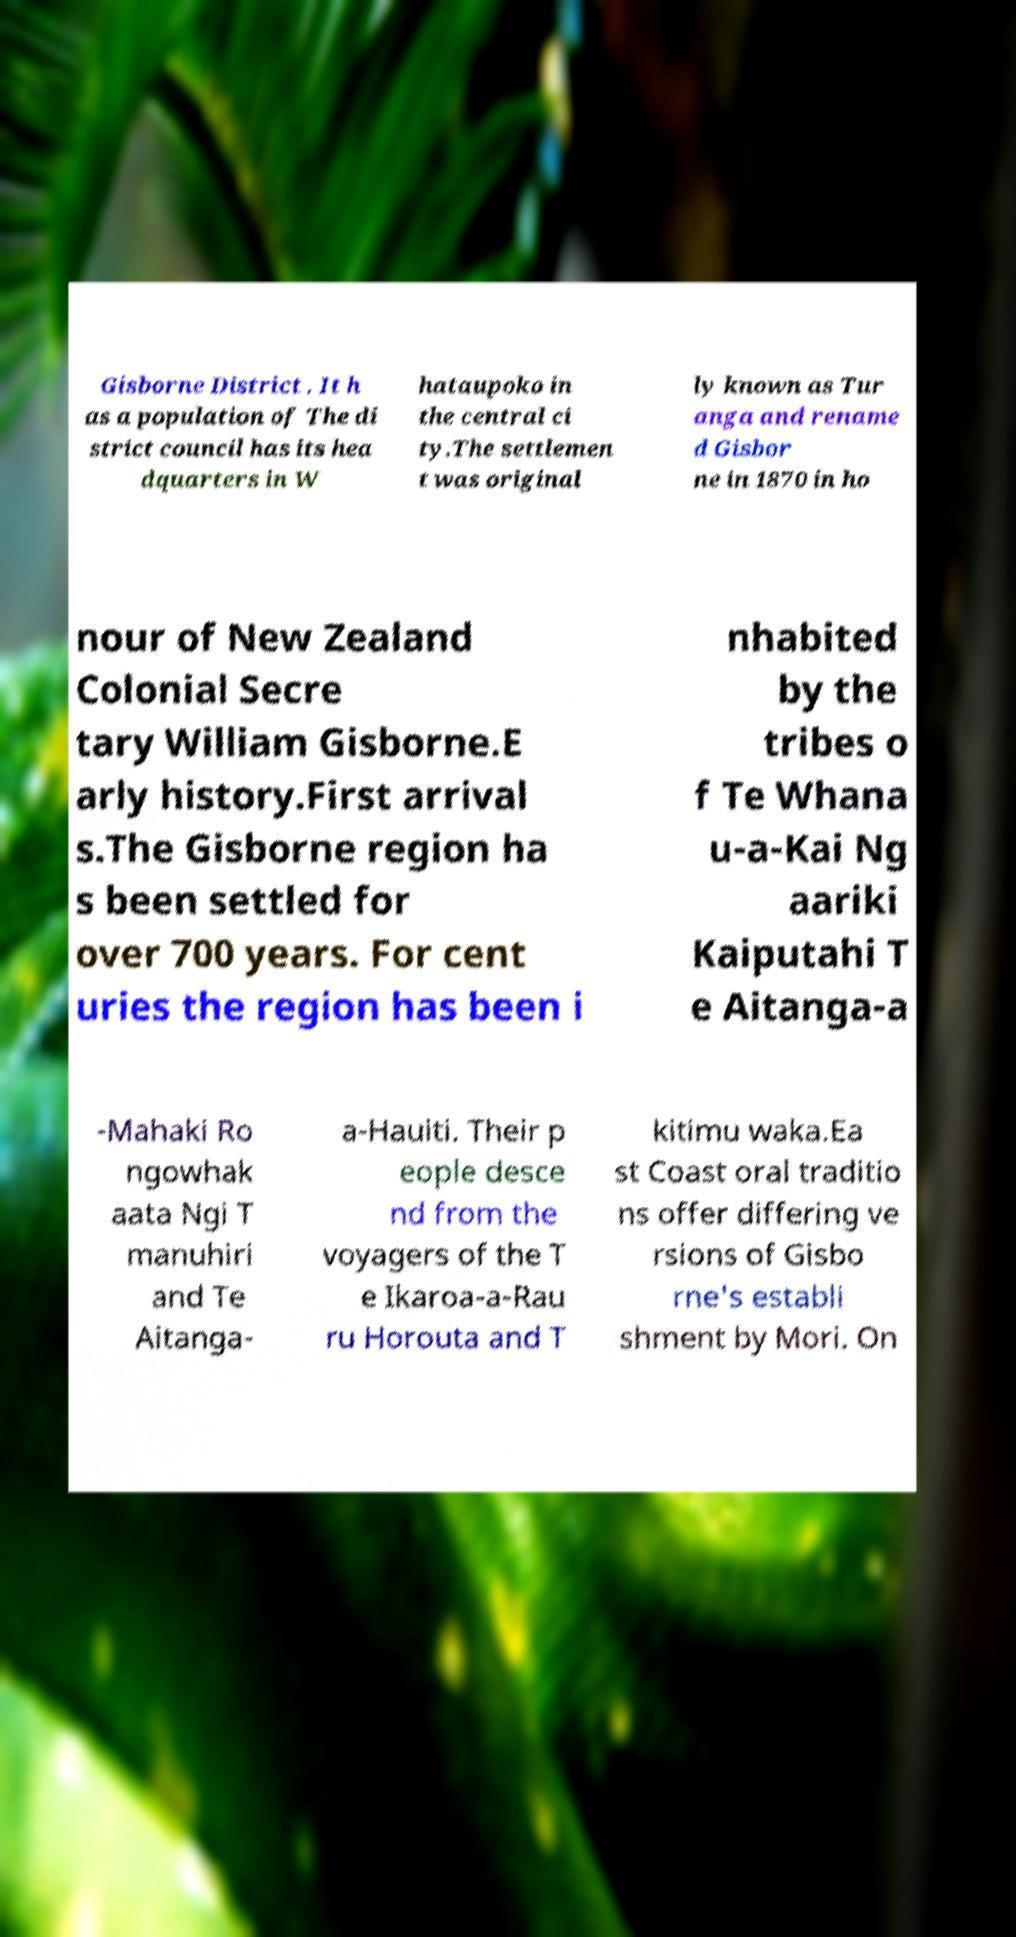Can you read and provide the text displayed in the image?This photo seems to have some interesting text. Can you extract and type it out for me? Gisborne District . It h as a population of The di strict council has its hea dquarters in W hataupoko in the central ci ty.The settlemen t was original ly known as Tur anga and rename d Gisbor ne in 1870 in ho nour of New Zealand Colonial Secre tary William Gisborne.E arly history.First arrival s.The Gisborne region ha s been settled for over 700 years. For cent uries the region has been i nhabited by the tribes o f Te Whana u-a-Kai Ng aariki Kaiputahi T e Aitanga-a -Mahaki Ro ngowhak aata Ngi T manuhiri and Te Aitanga- a-Hauiti. Their p eople desce nd from the voyagers of the T e Ikaroa-a-Rau ru Horouta and T kitimu waka.Ea st Coast oral traditio ns offer differing ve rsions of Gisbo rne's establi shment by Mori. On 